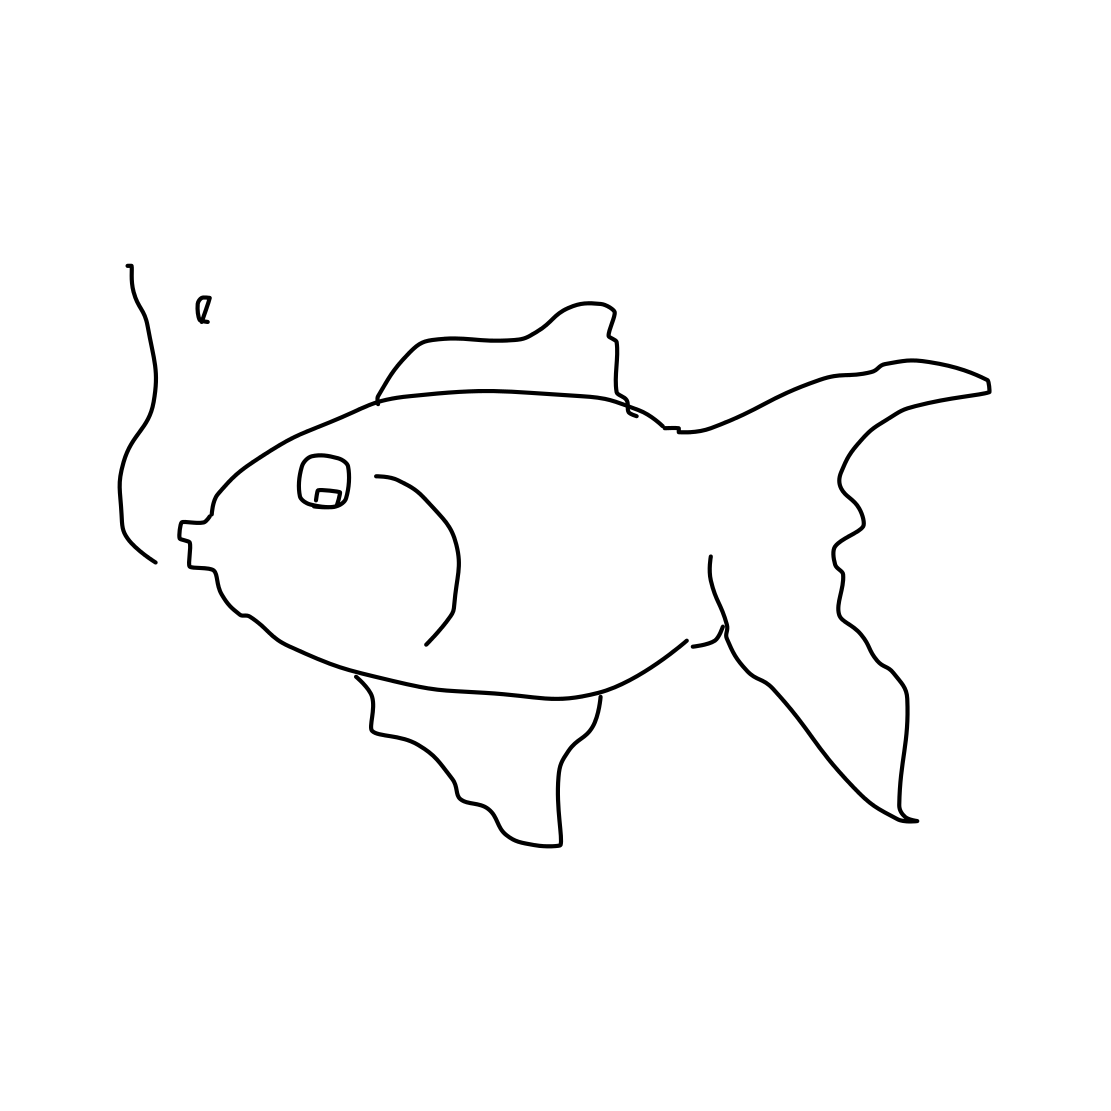Is there a sketchy wheel in the picture? No 